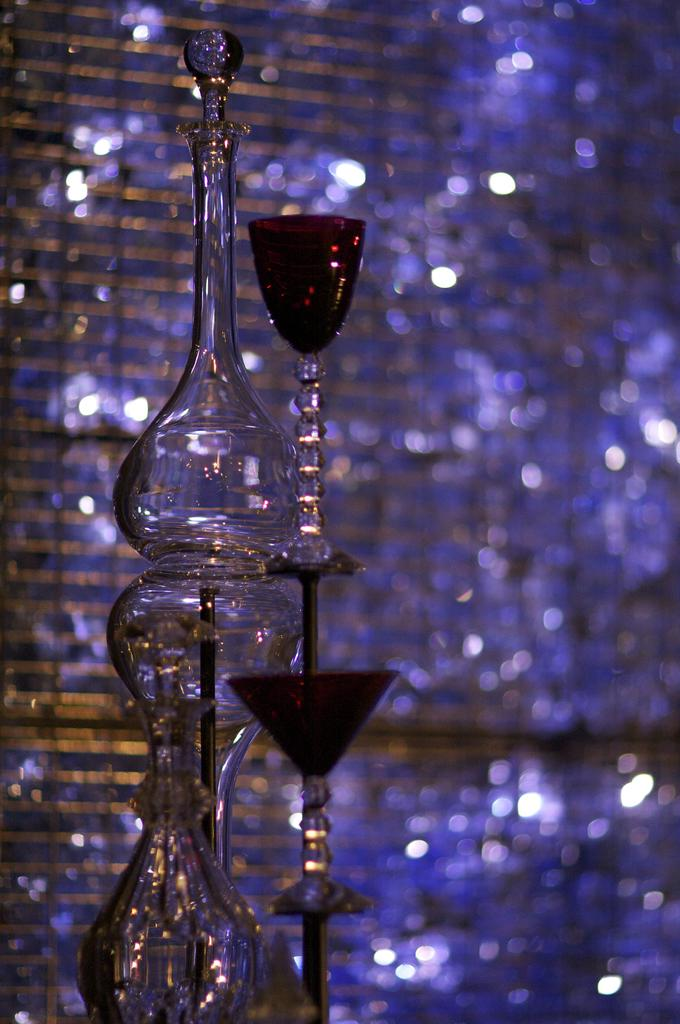What device is present in the image? There is a timer in the image. What is located above the timer? There is a glass beaker above the timer. What is positioned next to the beaker? There is a glass next to the beaker. What type of scarf is draped over the glass beaker in the image? There is no scarf present in the image; it only features a timer, a glass beaker, and a glass. What is the tendency of the glass beaker to change color in the image? There is no indication of the glass beaker changing color in the image, so it's not possible to determine its tendency. 